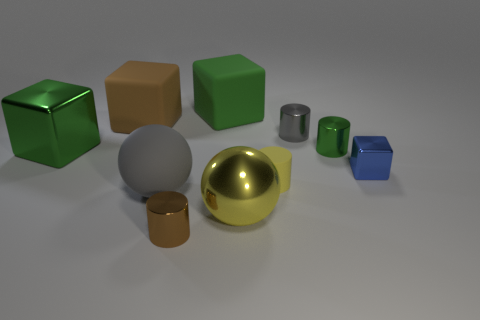Subtract all red balls. Subtract all brown cylinders. How many balls are left? 2 Subtract all cubes. How many objects are left? 6 Subtract all large yellow shiny balls. Subtract all big brown things. How many objects are left? 8 Add 1 blocks. How many blocks are left? 5 Add 1 big green objects. How many big green objects exist? 3 Subtract 0 blue cylinders. How many objects are left? 10 